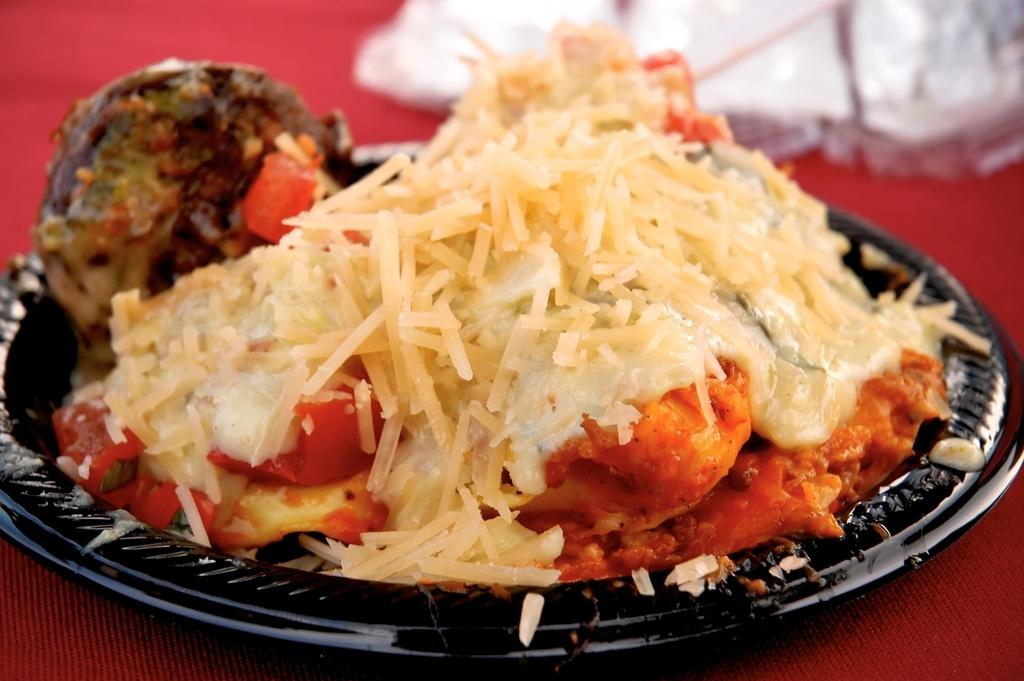What is on the plate in the image? There is a plate with food in the image. What color is the plate? The plate is black. How would you describe the food on the plate? The food is colorful. What other object can be seen in the image besides the plate? There is a white object in the image. What is the color of the surface on which the plate and the white object are placed? The plate and the white object are on a red surface. How many cows are visible in the image? There are no cows visible in the image. What type of scarf is being worn by the person in the image? There is no person or scarf present in the image. 